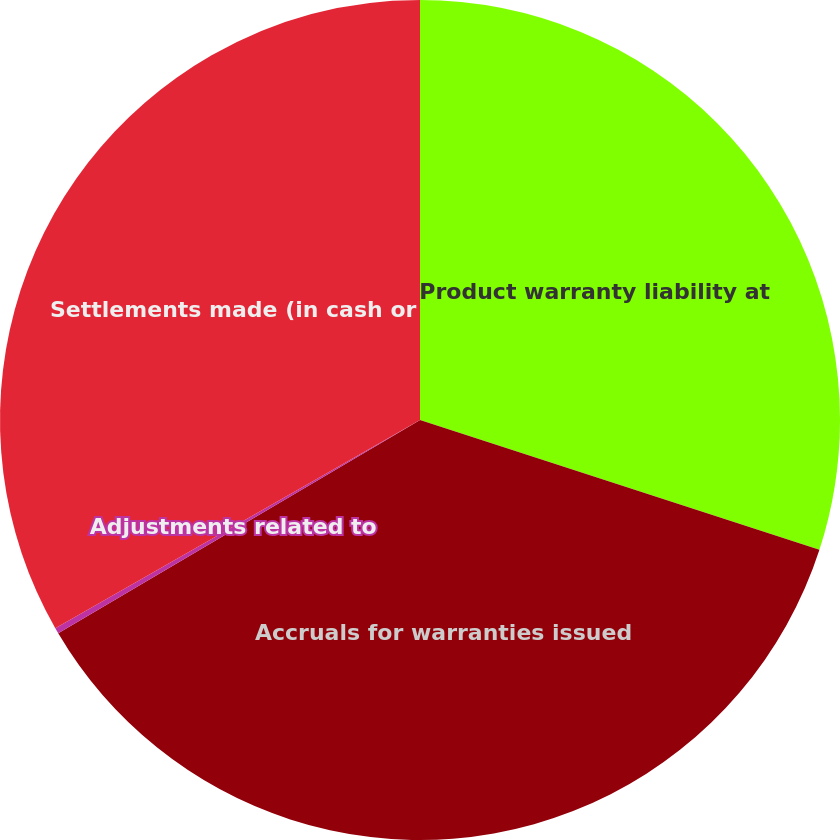<chart> <loc_0><loc_0><loc_500><loc_500><pie_chart><fcel>Product warranty liability at<fcel>Accruals for warranties issued<fcel>Adjustments related to<fcel>Settlements made (in cash or<nl><fcel>30.0%<fcel>36.52%<fcel>0.22%<fcel>33.26%<nl></chart> 